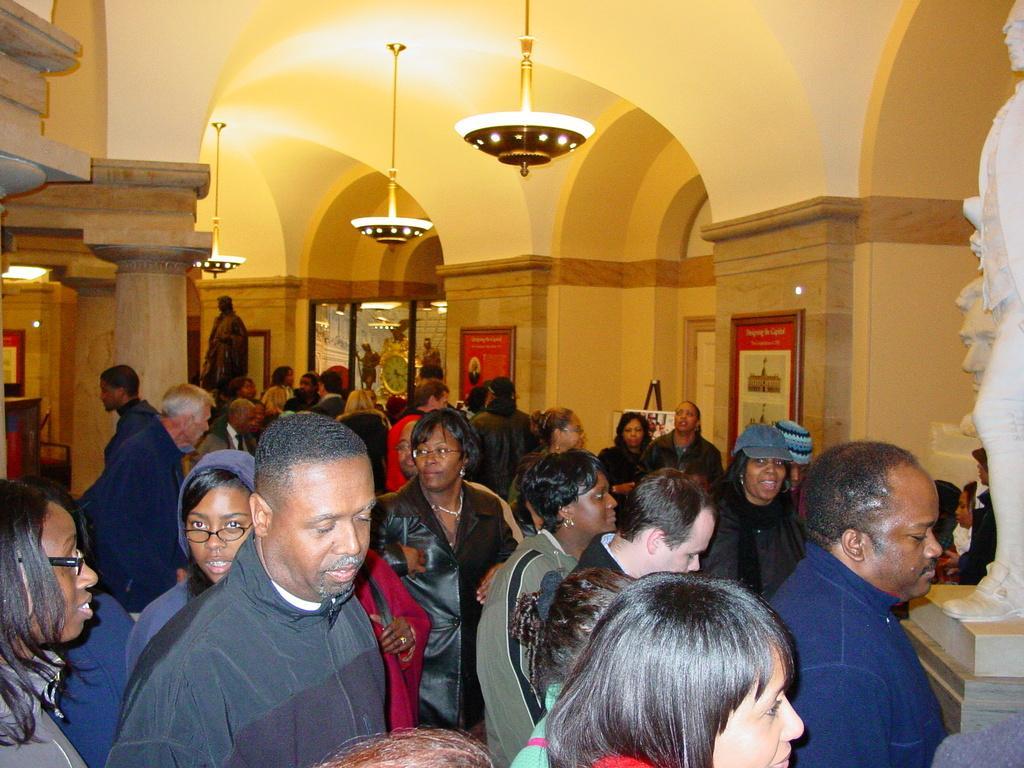How would you summarize this image in a sentence or two? In this picture we can see caps, spectacles, statues, frames, clock, lights, pillars and a group of people standing and some objects. 